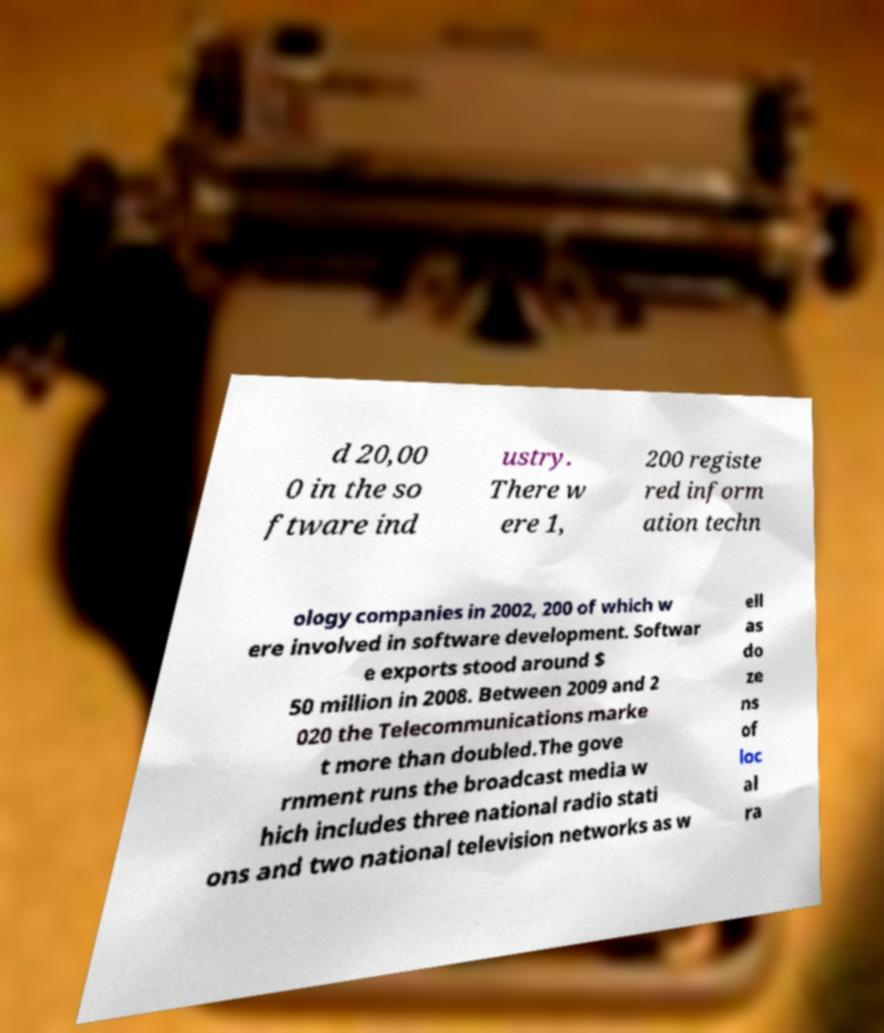What messages or text are displayed in this image? I need them in a readable, typed format. d 20,00 0 in the so ftware ind ustry. There w ere 1, 200 registe red inform ation techn ology companies in 2002, 200 of which w ere involved in software development. Softwar e exports stood around $ 50 million in 2008. Between 2009 and 2 020 the Telecommunications marke t more than doubled.The gove rnment runs the broadcast media w hich includes three national radio stati ons and two national television networks as w ell as do ze ns of loc al ra 